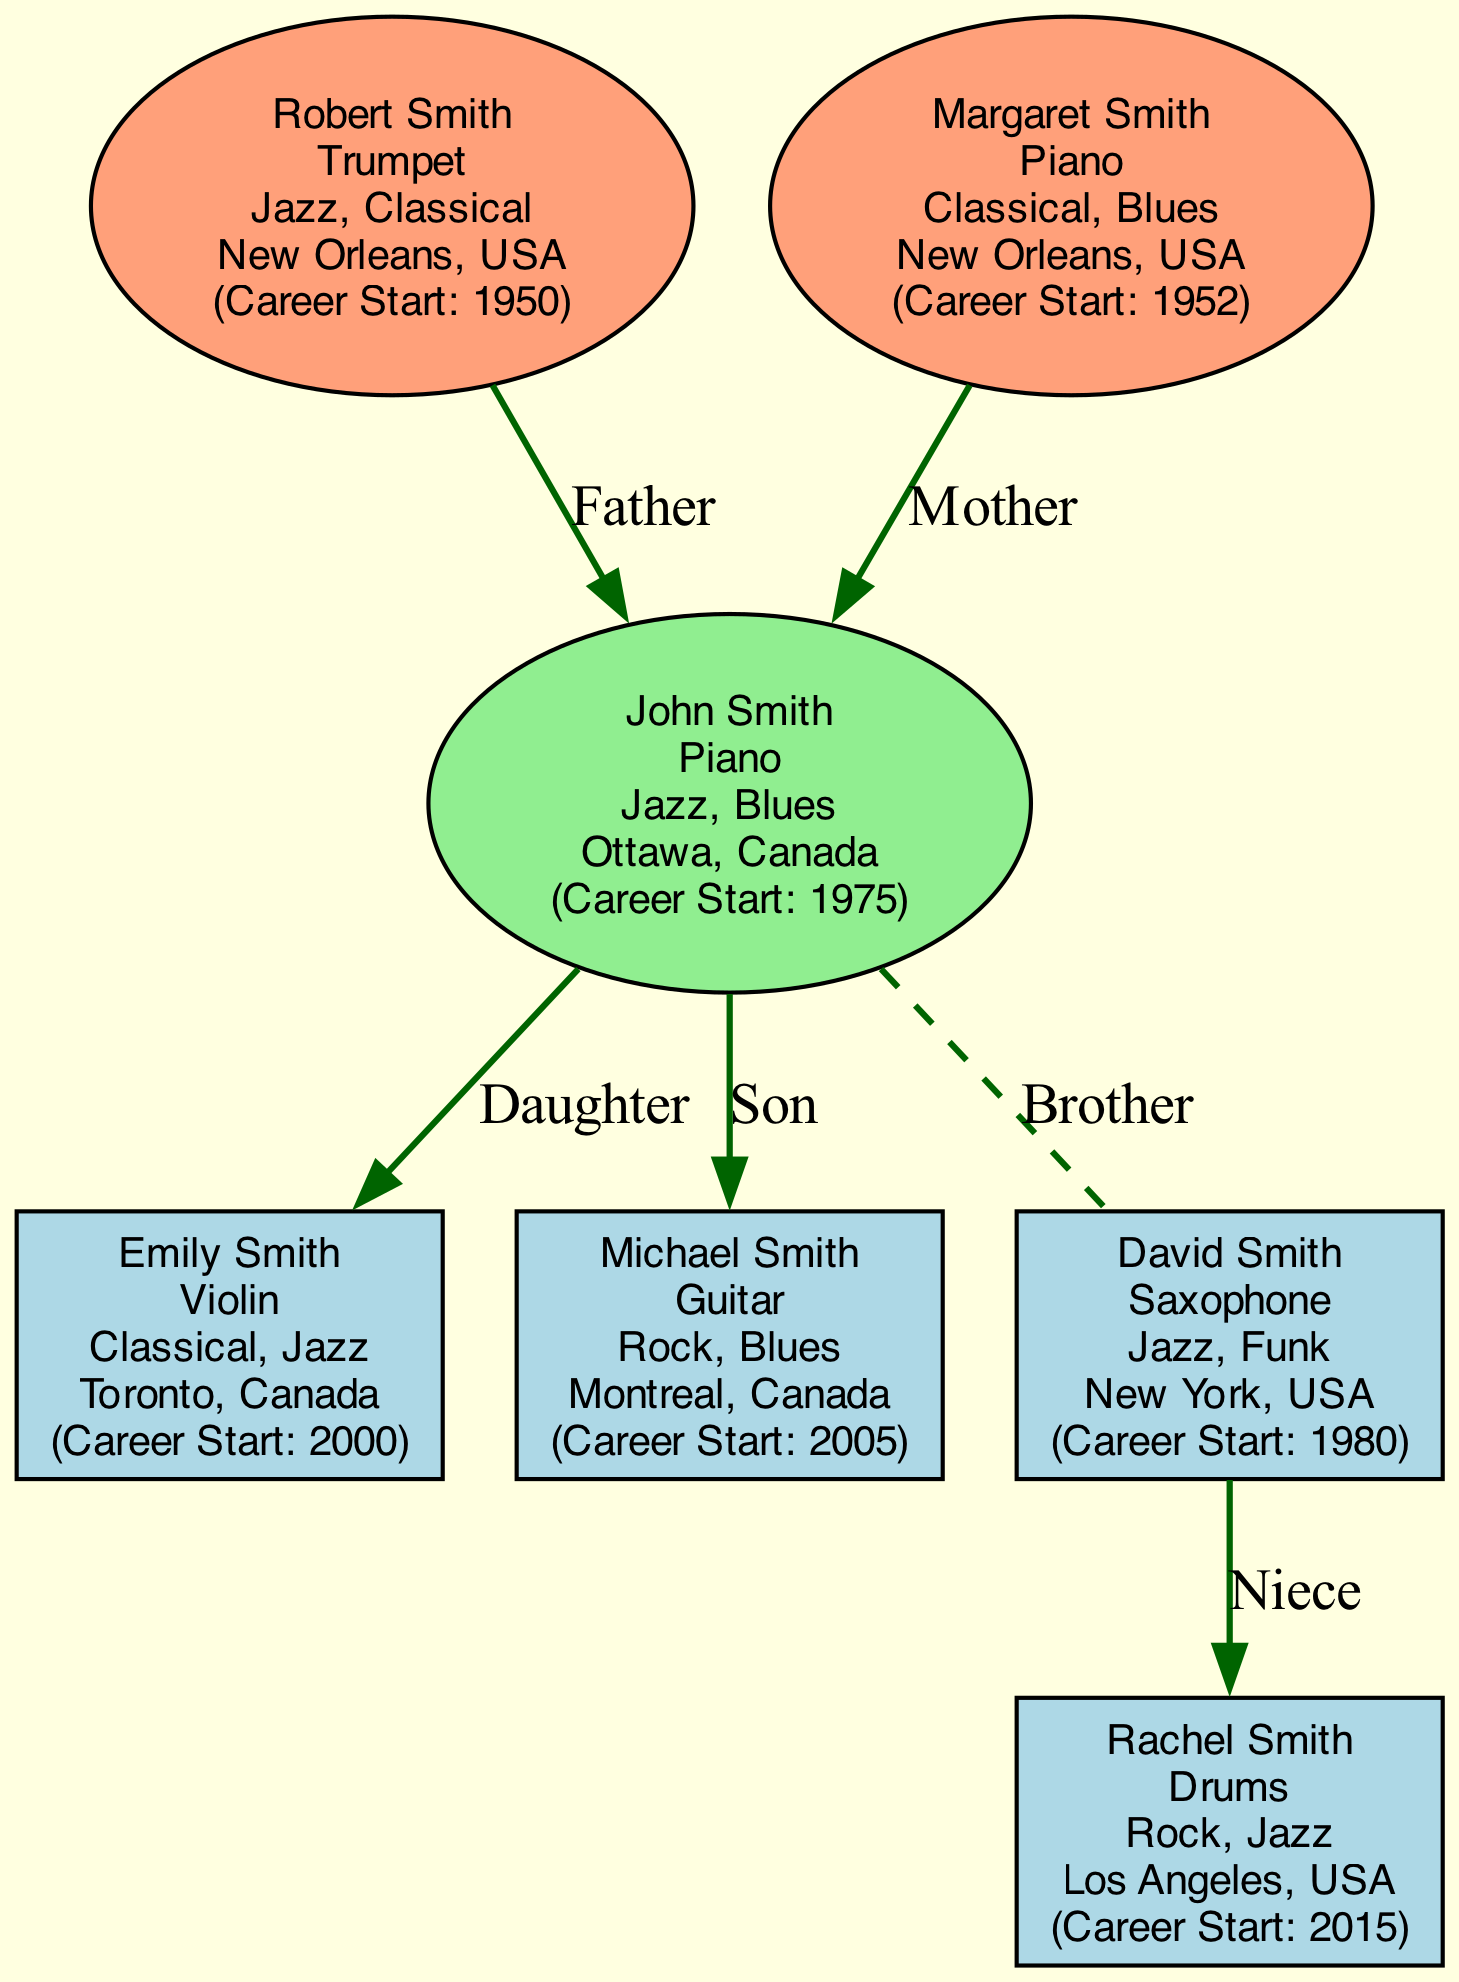What instrument does John Smith play? Looking at the root node of the diagram, it indicates that John Smith plays the Piano.
Answer: Piano How many children does John Smith have? The diagram contains a section that lists the children of John Smith, which includes Emily Smith and Michael Smith, totaling to two children.
Answer: 2 What genre does Michael Smith primarily play? By locating the node for Michael Smith, we see he is associated with the genres Rock and Blues, indicating these are the genres he primarily plays.
Answer: Rock, Blues Who is David Smith's niece? In the sibling section of the diagram, David Smith has a child named Rachel Smith. Thus, Rachel is identified as his niece.
Answer: Rachel Smith What instrument does Margaret Smith play? In the parents section of the diagram, it specifies that Margaret Smith plays the Piano, confirming her instrument.
Answer: Piano How many total career starts are represented in the family tree? The diagram shows individual career start years for each member: John (1975), Emily (2000), Michael (2005), David (1980), Robert (1950), Margaret (1952), and Rachel (2015). Counting these gives a total of 7 career starts represented.
Answer: 7 Which city does Emily Smith live in? The node for Emily Smith identifies her location as Toronto, Canada, confirming the city she resides in.
Answer: Toronto, Canada Which family member started their career first? By comparing the career start years given in the nodes, Robert Smith started the earliest in 1950, thus he is the family member who began their career first.
Answer: Robert Smith What genres are associated with David Smith? Looking at the node for David Smith, he is associated with Jazz and Funk genres, indicating the types of music he plays.
Answer: Jazz, Funk 